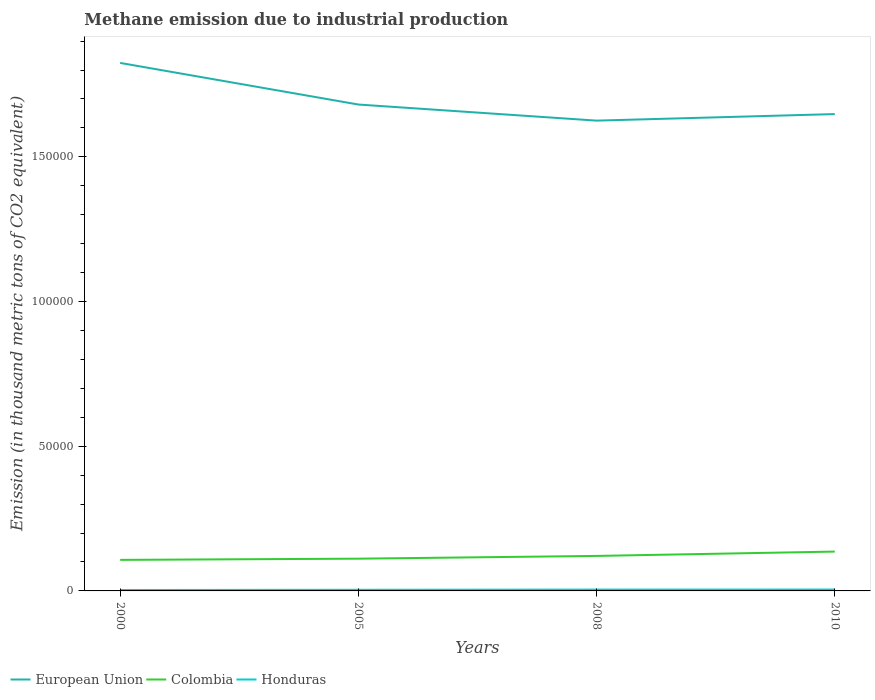How many different coloured lines are there?
Provide a succinct answer. 3. Is the number of lines equal to the number of legend labels?
Offer a very short reply. Yes. Across all years, what is the maximum amount of methane emitted in Colombia?
Provide a short and direct response. 1.07e+04. What is the total amount of methane emitted in Colombia in the graph?
Your answer should be very brief. -1501.6. What is the difference between the highest and the second highest amount of methane emitted in European Union?
Ensure brevity in your answer.  1.99e+04. Does the graph contain any zero values?
Provide a succinct answer. No. Does the graph contain grids?
Offer a terse response. No. Where does the legend appear in the graph?
Your answer should be very brief. Bottom left. How many legend labels are there?
Offer a terse response. 3. How are the legend labels stacked?
Offer a very short reply. Horizontal. What is the title of the graph?
Your answer should be very brief. Methane emission due to industrial production. What is the label or title of the X-axis?
Keep it short and to the point. Years. What is the label or title of the Y-axis?
Make the answer very short. Emission (in thousand metric tons of CO2 equivalent). What is the Emission (in thousand metric tons of CO2 equivalent) in European Union in 2000?
Your answer should be very brief. 1.82e+05. What is the Emission (in thousand metric tons of CO2 equivalent) in Colombia in 2000?
Give a very brief answer. 1.07e+04. What is the Emission (in thousand metric tons of CO2 equivalent) of Honduras in 2000?
Provide a succinct answer. 315.9. What is the Emission (in thousand metric tons of CO2 equivalent) of European Union in 2005?
Ensure brevity in your answer.  1.68e+05. What is the Emission (in thousand metric tons of CO2 equivalent) of Colombia in 2005?
Your answer should be very brief. 1.11e+04. What is the Emission (in thousand metric tons of CO2 equivalent) of Honduras in 2005?
Provide a short and direct response. 393.2. What is the Emission (in thousand metric tons of CO2 equivalent) in European Union in 2008?
Make the answer very short. 1.63e+05. What is the Emission (in thousand metric tons of CO2 equivalent) of Colombia in 2008?
Offer a very short reply. 1.21e+04. What is the Emission (in thousand metric tons of CO2 equivalent) in Honduras in 2008?
Provide a succinct answer. 461.7. What is the Emission (in thousand metric tons of CO2 equivalent) in European Union in 2010?
Your answer should be very brief. 1.65e+05. What is the Emission (in thousand metric tons of CO2 equivalent) of Colombia in 2010?
Ensure brevity in your answer.  1.36e+04. What is the Emission (in thousand metric tons of CO2 equivalent) in Honduras in 2010?
Your answer should be very brief. 478.1. Across all years, what is the maximum Emission (in thousand metric tons of CO2 equivalent) in European Union?
Offer a very short reply. 1.82e+05. Across all years, what is the maximum Emission (in thousand metric tons of CO2 equivalent) in Colombia?
Your answer should be compact. 1.36e+04. Across all years, what is the maximum Emission (in thousand metric tons of CO2 equivalent) in Honduras?
Your answer should be very brief. 478.1. Across all years, what is the minimum Emission (in thousand metric tons of CO2 equivalent) of European Union?
Provide a short and direct response. 1.63e+05. Across all years, what is the minimum Emission (in thousand metric tons of CO2 equivalent) of Colombia?
Offer a very short reply. 1.07e+04. Across all years, what is the minimum Emission (in thousand metric tons of CO2 equivalent) in Honduras?
Ensure brevity in your answer.  315.9. What is the total Emission (in thousand metric tons of CO2 equivalent) of European Union in the graph?
Provide a short and direct response. 6.78e+05. What is the total Emission (in thousand metric tons of CO2 equivalent) in Colombia in the graph?
Ensure brevity in your answer.  4.76e+04. What is the total Emission (in thousand metric tons of CO2 equivalent) in Honduras in the graph?
Give a very brief answer. 1648.9. What is the difference between the Emission (in thousand metric tons of CO2 equivalent) of European Union in 2000 and that in 2005?
Offer a very short reply. 1.44e+04. What is the difference between the Emission (in thousand metric tons of CO2 equivalent) in Colombia in 2000 and that in 2005?
Your answer should be very brief. -413.7. What is the difference between the Emission (in thousand metric tons of CO2 equivalent) in Honduras in 2000 and that in 2005?
Your response must be concise. -77.3. What is the difference between the Emission (in thousand metric tons of CO2 equivalent) of European Union in 2000 and that in 2008?
Provide a short and direct response. 1.99e+04. What is the difference between the Emission (in thousand metric tons of CO2 equivalent) of Colombia in 2000 and that in 2008?
Your response must be concise. -1363.7. What is the difference between the Emission (in thousand metric tons of CO2 equivalent) in Honduras in 2000 and that in 2008?
Make the answer very short. -145.8. What is the difference between the Emission (in thousand metric tons of CO2 equivalent) in European Union in 2000 and that in 2010?
Keep it short and to the point. 1.77e+04. What is the difference between the Emission (in thousand metric tons of CO2 equivalent) of Colombia in 2000 and that in 2010?
Your answer should be very brief. -2865.3. What is the difference between the Emission (in thousand metric tons of CO2 equivalent) in Honduras in 2000 and that in 2010?
Ensure brevity in your answer.  -162.2. What is the difference between the Emission (in thousand metric tons of CO2 equivalent) in European Union in 2005 and that in 2008?
Provide a succinct answer. 5562. What is the difference between the Emission (in thousand metric tons of CO2 equivalent) in Colombia in 2005 and that in 2008?
Ensure brevity in your answer.  -950. What is the difference between the Emission (in thousand metric tons of CO2 equivalent) in Honduras in 2005 and that in 2008?
Your answer should be compact. -68.5. What is the difference between the Emission (in thousand metric tons of CO2 equivalent) of European Union in 2005 and that in 2010?
Keep it short and to the point. 3298.2. What is the difference between the Emission (in thousand metric tons of CO2 equivalent) in Colombia in 2005 and that in 2010?
Give a very brief answer. -2451.6. What is the difference between the Emission (in thousand metric tons of CO2 equivalent) of Honduras in 2005 and that in 2010?
Ensure brevity in your answer.  -84.9. What is the difference between the Emission (in thousand metric tons of CO2 equivalent) in European Union in 2008 and that in 2010?
Offer a terse response. -2263.8. What is the difference between the Emission (in thousand metric tons of CO2 equivalent) in Colombia in 2008 and that in 2010?
Provide a succinct answer. -1501.6. What is the difference between the Emission (in thousand metric tons of CO2 equivalent) of Honduras in 2008 and that in 2010?
Provide a short and direct response. -16.4. What is the difference between the Emission (in thousand metric tons of CO2 equivalent) in European Union in 2000 and the Emission (in thousand metric tons of CO2 equivalent) in Colombia in 2005?
Your answer should be very brief. 1.71e+05. What is the difference between the Emission (in thousand metric tons of CO2 equivalent) in European Union in 2000 and the Emission (in thousand metric tons of CO2 equivalent) in Honduras in 2005?
Provide a succinct answer. 1.82e+05. What is the difference between the Emission (in thousand metric tons of CO2 equivalent) in Colombia in 2000 and the Emission (in thousand metric tons of CO2 equivalent) in Honduras in 2005?
Offer a very short reply. 1.03e+04. What is the difference between the Emission (in thousand metric tons of CO2 equivalent) of European Union in 2000 and the Emission (in thousand metric tons of CO2 equivalent) of Colombia in 2008?
Provide a succinct answer. 1.70e+05. What is the difference between the Emission (in thousand metric tons of CO2 equivalent) of European Union in 2000 and the Emission (in thousand metric tons of CO2 equivalent) of Honduras in 2008?
Ensure brevity in your answer.  1.82e+05. What is the difference between the Emission (in thousand metric tons of CO2 equivalent) in Colombia in 2000 and the Emission (in thousand metric tons of CO2 equivalent) in Honduras in 2008?
Keep it short and to the point. 1.03e+04. What is the difference between the Emission (in thousand metric tons of CO2 equivalent) in European Union in 2000 and the Emission (in thousand metric tons of CO2 equivalent) in Colombia in 2010?
Give a very brief answer. 1.69e+05. What is the difference between the Emission (in thousand metric tons of CO2 equivalent) in European Union in 2000 and the Emission (in thousand metric tons of CO2 equivalent) in Honduras in 2010?
Give a very brief answer. 1.82e+05. What is the difference between the Emission (in thousand metric tons of CO2 equivalent) in Colombia in 2000 and the Emission (in thousand metric tons of CO2 equivalent) in Honduras in 2010?
Keep it short and to the point. 1.03e+04. What is the difference between the Emission (in thousand metric tons of CO2 equivalent) in European Union in 2005 and the Emission (in thousand metric tons of CO2 equivalent) in Colombia in 2008?
Keep it short and to the point. 1.56e+05. What is the difference between the Emission (in thousand metric tons of CO2 equivalent) of European Union in 2005 and the Emission (in thousand metric tons of CO2 equivalent) of Honduras in 2008?
Offer a very short reply. 1.68e+05. What is the difference between the Emission (in thousand metric tons of CO2 equivalent) in Colombia in 2005 and the Emission (in thousand metric tons of CO2 equivalent) in Honduras in 2008?
Your response must be concise. 1.07e+04. What is the difference between the Emission (in thousand metric tons of CO2 equivalent) of European Union in 2005 and the Emission (in thousand metric tons of CO2 equivalent) of Colombia in 2010?
Your response must be concise. 1.54e+05. What is the difference between the Emission (in thousand metric tons of CO2 equivalent) in European Union in 2005 and the Emission (in thousand metric tons of CO2 equivalent) in Honduras in 2010?
Give a very brief answer. 1.68e+05. What is the difference between the Emission (in thousand metric tons of CO2 equivalent) of Colombia in 2005 and the Emission (in thousand metric tons of CO2 equivalent) of Honduras in 2010?
Your answer should be compact. 1.07e+04. What is the difference between the Emission (in thousand metric tons of CO2 equivalent) of European Union in 2008 and the Emission (in thousand metric tons of CO2 equivalent) of Colombia in 2010?
Make the answer very short. 1.49e+05. What is the difference between the Emission (in thousand metric tons of CO2 equivalent) of European Union in 2008 and the Emission (in thousand metric tons of CO2 equivalent) of Honduras in 2010?
Make the answer very short. 1.62e+05. What is the difference between the Emission (in thousand metric tons of CO2 equivalent) in Colombia in 2008 and the Emission (in thousand metric tons of CO2 equivalent) in Honduras in 2010?
Your answer should be very brief. 1.16e+04. What is the average Emission (in thousand metric tons of CO2 equivalent) of European Union per year?
Your answer should be very brief. 1.69e+05. What is the average Emission (in thousand metric tons of CO2 equivalent) of Colombia per year?
Provide a succinct answer. 1.19e+04. What is the average Emission (in thousand metric tons of CO2 equivalent) in Honduras per year?
Ensure brevity in your answer.  412.23. In the year 2000, what is the difference between the Emission (in thousand metric tons of CO2 equivalent) of European Union and Emission (in thousand metric tons of CO2 equivalent) of Colombia?
Your response must be concise. 1.72e+05. In the year 2000, what is the difference between the Emission (in thousand metric tons of CO2 equivalent) in European Union and Emission (in thousand metric tons of CO2 equivalent) in Honduras?
Make the answer very short. 1.82e+05. In the year 2000, what is the difference between the Emission (in thousand metric tons of CO2 equivalent) in Colombia and Emission (in thousand metric tons of CO2 equivalent) in Honduras?
Give a very brief answer. 1.04e+04. In the year 2005, what is the difference between the Emission (in thousand metric tons of CO2 equivalent) of European Union and Emission (in thousand metric tons of CO2 equivalent) of Colombia?
Ensure brevity in your answer.  1.57e+05. In the year 2005, what is the difference between the Emission (in thousand metric tons of CO2 equivalent) of European Union and Emission (in thousand metric tons of CO2 equivalent) of Honduras?
Provide a succinct answer. 1.68e+05. In the year 2005, what is the difference between the Emission (in thousand metric tons of CO2 equivalent) in Colombia and Emission (in thousand metric tons of CO2 equivalent) in Honduras?
Your response must be concise. 1.07e+04. In the year 2008, what is the difference between the Emission (in thousand metric tons of CO2 equivalent) of European Union and Emission (in thousand metric tons of CO2 equivalent) of Colombia?
Offer a very short reply. 1.50e+05. In the year 2008, what is the difference between the Emission (in thousand metric tons of CO2 equivalent) in European Union and Emission (in thousand metric tons of CO2 equivalent) in Honduras?
Your answer should be compact. 1.62e+05. In the year 2008, what is the difference between the Emission (in thousand metric tons of CO2 equivalent) of Colombia and Emission (in thousand metric tons of CO2 equivalent) of Honduras?
Your answer should be compact. 1.16e+04. In the year 2010, what is the difference between the Emission (in thousand metric tons of CO2 equivalent) of European Union and Emission (in thousand metric tons of CO2 equivalent) of Colombia?
Your response must be concise. 1.51e+05. In the year 2010, what is the difference between the Emission (in thousand metric tons of CO2 equivalent) of European Union and Emission (in thousand metric tons of CO2 equivalent) of Honduras?
Offer a terse response. 1.64e+05. In the year 2010, what is the difference between the Emission (in thousand metric tons of CO2 equivalent) of Colombia and Emission (in thousand metric tons of CO2 equivalent) of Honduras?
Keep it short and to the point. 1.31e+04. What is the ratio of the Emission (in thousand metric tons of CO2 equivalent) of European Union in 2000 to that in 2005?
Your answer should be very brief. 1.09. What is the ratio of the Emission (in thousand metric tons of CO2 equivalent) in Colombia in 2000 to that in 2005?
Ensure brevity in your answer.  0.96. What is the ratio of the Emission (in thousand metric tons of CO2 equivalent) in Honduras in 2000 to that in 2005?
Offer a terse response. 0.8. What is the ratio of the Emission (in thousand metric tons of CO2 equivalent) in European Union in 2000 to that in 2008?
Offer a very short reply. 1.12. What is the ratio of the Emission (in thousand metric tons of CO2 equivalent) in Colombia in 2000 to that in 2008?
Your answer should be very brief. 0.89. What is the ratio of the Emission (in thousand metric tons of CO2 equivalent) in Honduras in 2000 to that in 2008?
Your answer should be compact. 0.68. What is the ratio of the Emission (in thousand metric tons of CO2 equivalent) of European Union in 2000 to that in 2010?
Give a very brief answer. 1.11. What is the ratio of the Emission (in thousand metric tons of CO2 equivalent) in Colombia in 2000 to that in 2010?
Ensure brevity in your answer.  0.79. What is the ratio of the Emission (in thousand metric tons of CO2 equivalent) in Honduras in 2000 to that in 2010?
Your answer should be very brief. 0.66. What is the ratio of the Emission (in thousand metric tons of CO2 equivalent) of European Union in 2005 to that in 2008?
Offer a terse response. 1.03. What is the ratio of the Emission (in thousand metric tons of CO2 equivalent) in Colombia in 2005 to that in 2008?
Make the answer very short. 0.92. What is the ratio of the Emission (in thousand metric tons of CO2 equivalent) in Honduras in 2005 to that in 2008?
Give a very brief answer. 0.85. What is the ratio of the Emission (in thousand metric tons of CO2 equivalent) of European Union in 2005 to that in 2010?
Provide a succinct answer. 1.02. What is the ratio of the Emission (in thousand metric tons of CO2 equivalent) of Colombia in 2005 to that in 2010?
Keep it short and to the point. 0.82. What is the ratio of the Emission (in thousand metric tons of CO2 equivalent) of Honduras in 2005 to that in 2010?
Ensure brevity in your answer.  0.82. What is the ratio of the Emission (in thousand metric tons of CO2 equivalent) in European Union in 2008 to that in 2010?
Provide a succinct answer. 0.99. What is the ratio of the Emission (in thousand metric tons of CO2 equivalent) in Colombia in 2008 to that in 2010?
Your answer should be compact. 0.89. What is the ratio of the Emission (in thousand metric tons of CO2 equivalent) of Honduras in 2008 to that in 2010?
Make the answer very short. 0.97. What is the difference between the highest and the second highest Emission (in thousand metric tons of CO2 equivalent) of European Union?
Offer a very short reply. 1.44e+04. What is the difference between the highest and the second highest Emission (in thousand metric tons of CO2 equivalent) of Colombia?
Provide a succinct answer. 1501.6. What is the difference between the highest and the lowest Emission (in thousand metric tons of CO2 equivalent) in European Union?
Give a very brief answer. 1.99e+04. What is the difference between the highest and the lowest Emission (in thousand metric tons of CO2 equivalent) of Colombia?
Make the answer very short. 2865.3. What is the difference between the highest and the lowest Emission (in thousand metric tons of CO2 equivalent) of Honduras?
Make the answer very short. 162.2. 